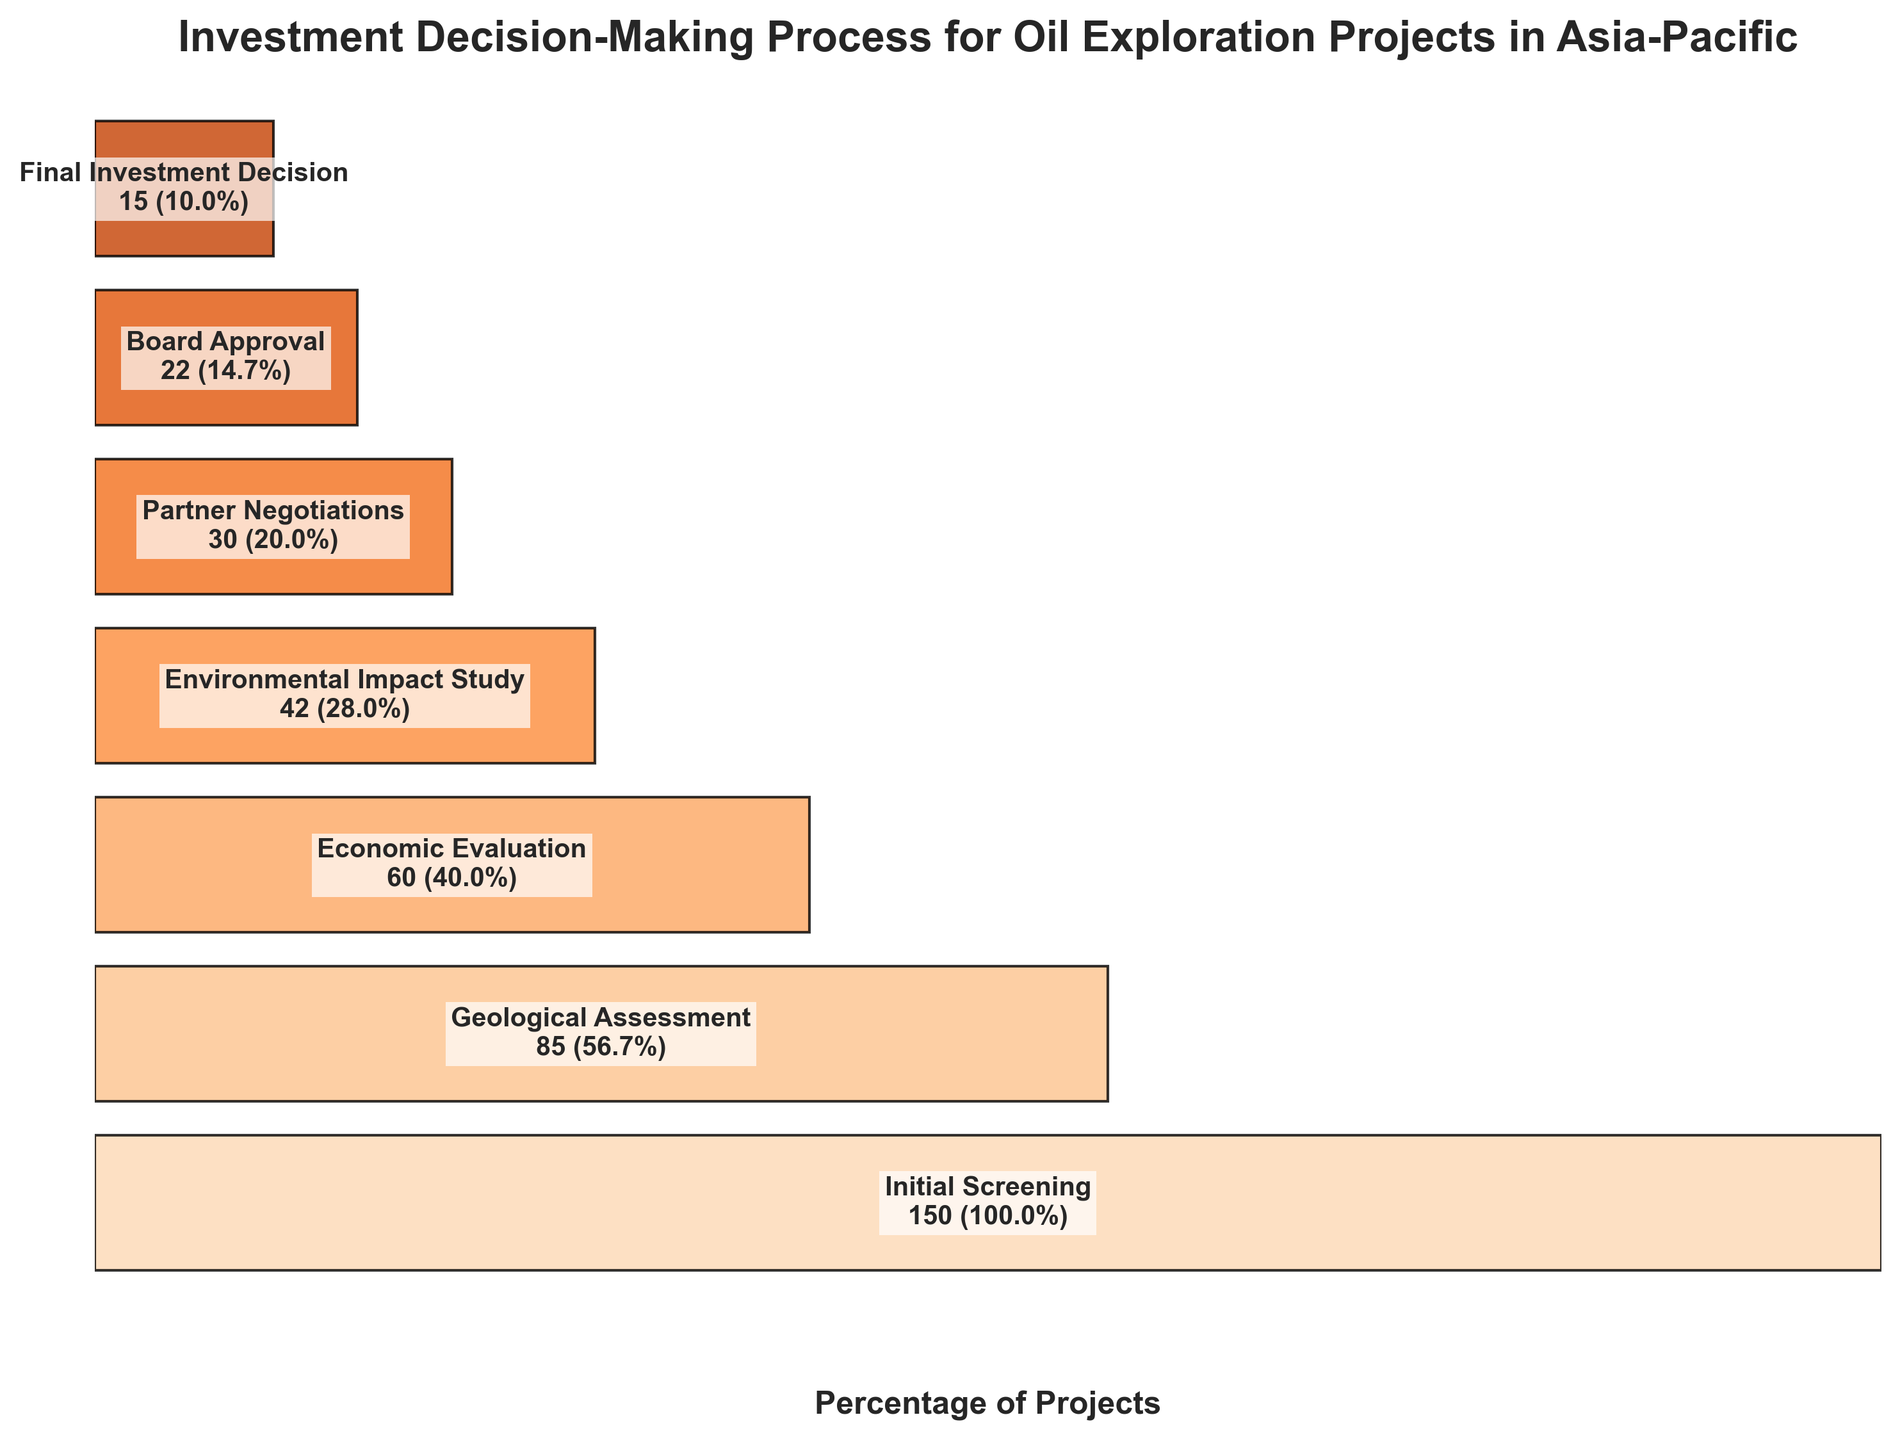what is the title of the chart? The title is written at the top of the chart. It reads: "Investment Decision-Making Process for Oil Exploration Projects in Asia-Pacific".
Answer: Investment Decision-Making Process for Oil Exploration Projects in Asia-Pacific How many projects are there at the initial screening stage? The number of projects at each stage is listed in the text inside the chart. For the initial screening stage, it shows 150 projects.
Answer: 150 Which stage has the highest percentage of projects proceeding to the next stage after the initial screening? The highest percentage of projects proceeding to the next stage can be determined by comparing the percentages listed for each stage. The initial screening shows 100%, but the next stages have percentages less than 100%. Therefore, the initial screening has the highest percentage.
Answer: Initial Screening How many stages are involved in the decision-making process? To determine the number of stages, count the number of unique stages listed vertically on the chart. There are seven stages listed.
Answer: 7 What percentage of projects reach the final investment decision stage? The percentage for each stage is denoted in the chart. For the final investment decision stage, it is mentioned as 10%.
Answer: 10% Compare the number of projects in the geological assessment stage to those in the economic evaluation stage. Which stage has more projects? The number of projects in each stage is stated in the chart. The geological assessment stage has 85 projects, whereas the economic evaluation stage has 60 projects. Geological assessment has more projects.
Answer: Geological Assessment What is the difference in the number of projects between the environmental impact study and partner negotiations stages? The number of projects in the environmental impact study stage is 42, and in the partner negotiations stage is 30. Subtract the latter from the former (42 - 30) to get the difference, which is 12.
Answer: 12 What is the percentage decrease in projects from the geological assessment stage to the final investment decision stage? The geological assessment starts with 85 projects (56.7%), and the final investment decision ends with 15 projects (10%). First, convert percentages to proportions (56.7% = 0.567 and 10% = 0.1). Then, calculate the percentage decrease: (0.567 - 0.1) / 0.567 * 100 = 82.36%.
Answer: 82.36% Which stages have less than 30% of the initial projects proceeding to the next stage? By inspecting the chart's percentages, the stages with less than 30% are Environmental Impact Study (28%), Partner Negotiations (20%), Board Approval (14.7%), and Final Investment Decision (10%).
Answer: Environmental Impact Study, Partner Negotiations, Board Approval, Final Investment Decision What is the percentage of projects lost between the initial screening and board approval stages? The initial screening has 150 projects (100%), and the board approval stage has 22 projects (14.7%). Calculate the percentage loss: (150 - 22) / 150 * 100 = 85.33%.
Answer: 85.33% 